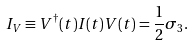Convert formula to latex. <formula><loc_0><loc_0><loc_500><loc_500>I _ { V } \equiv V ^ { \dagger } ( t ) I ( t ) V ( t ) = \frac { 1 } { 2 } \sigma _ { 3 } .</formula> 